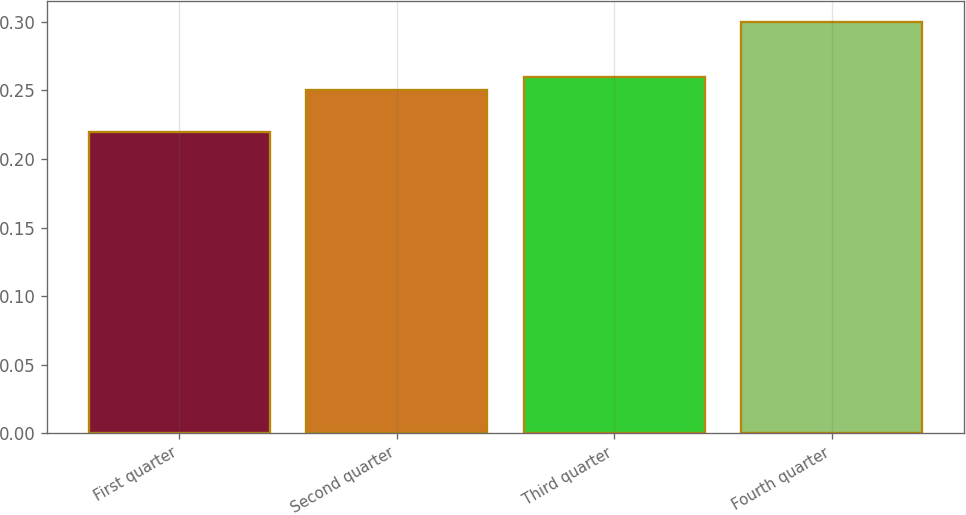Convert chart to OTSL. <chart><loc_0><loc_0><loc_500><loc_500><bar_chart><fcel>First quarter<fcel>Second quarter<fcel>Third quarter<fcel>Fourth quarter<nl><fcel>0.22<fcel>0.25<fcel>0.26<fcel>0.3<nl></chart> 